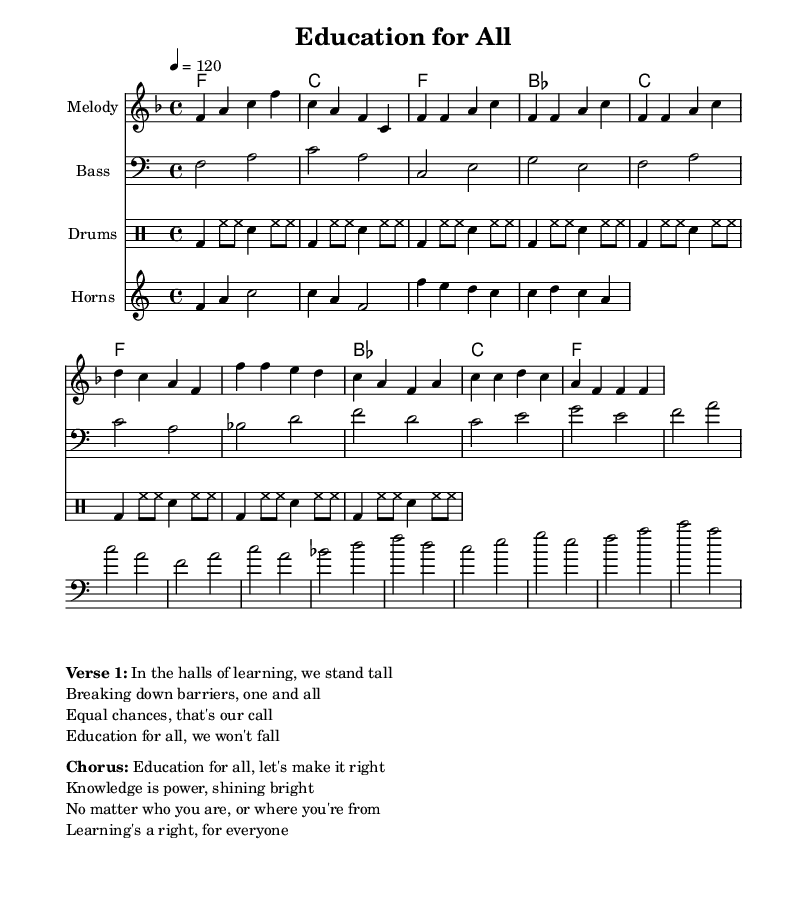What is the key signature of this music? The key signature shows one flat, indicating it is in F major.
Answer: F major What is the time signature of this piece? The time signature is indicated as 4/4, meaning there are four beats per measure.
Answer: 4/4 What is the tempo marking for this piece? The tempo marking indicates 120 beats per minute, which is a moderate pace for the song.
Answer: 120 How many measures are in the chorus section? There are four measures in the chorus section indicated in the score.
Answer: 4 Which instruments are included in the score? The score includes melody, bass, drums, and horns, as listed in the instrumentation.
Answer: Melody, bass, drums, horns What is the main theme of the lyrics in the verse? The main theme addresses educational equity and breaking down barriers to provide equal opportunities in education.
Answer: Educational equity What musical form does this piece primarily follow? The piece follows a verse-chorus structure, common in rhythm and blues genres.
Answer: Verse-chorus 